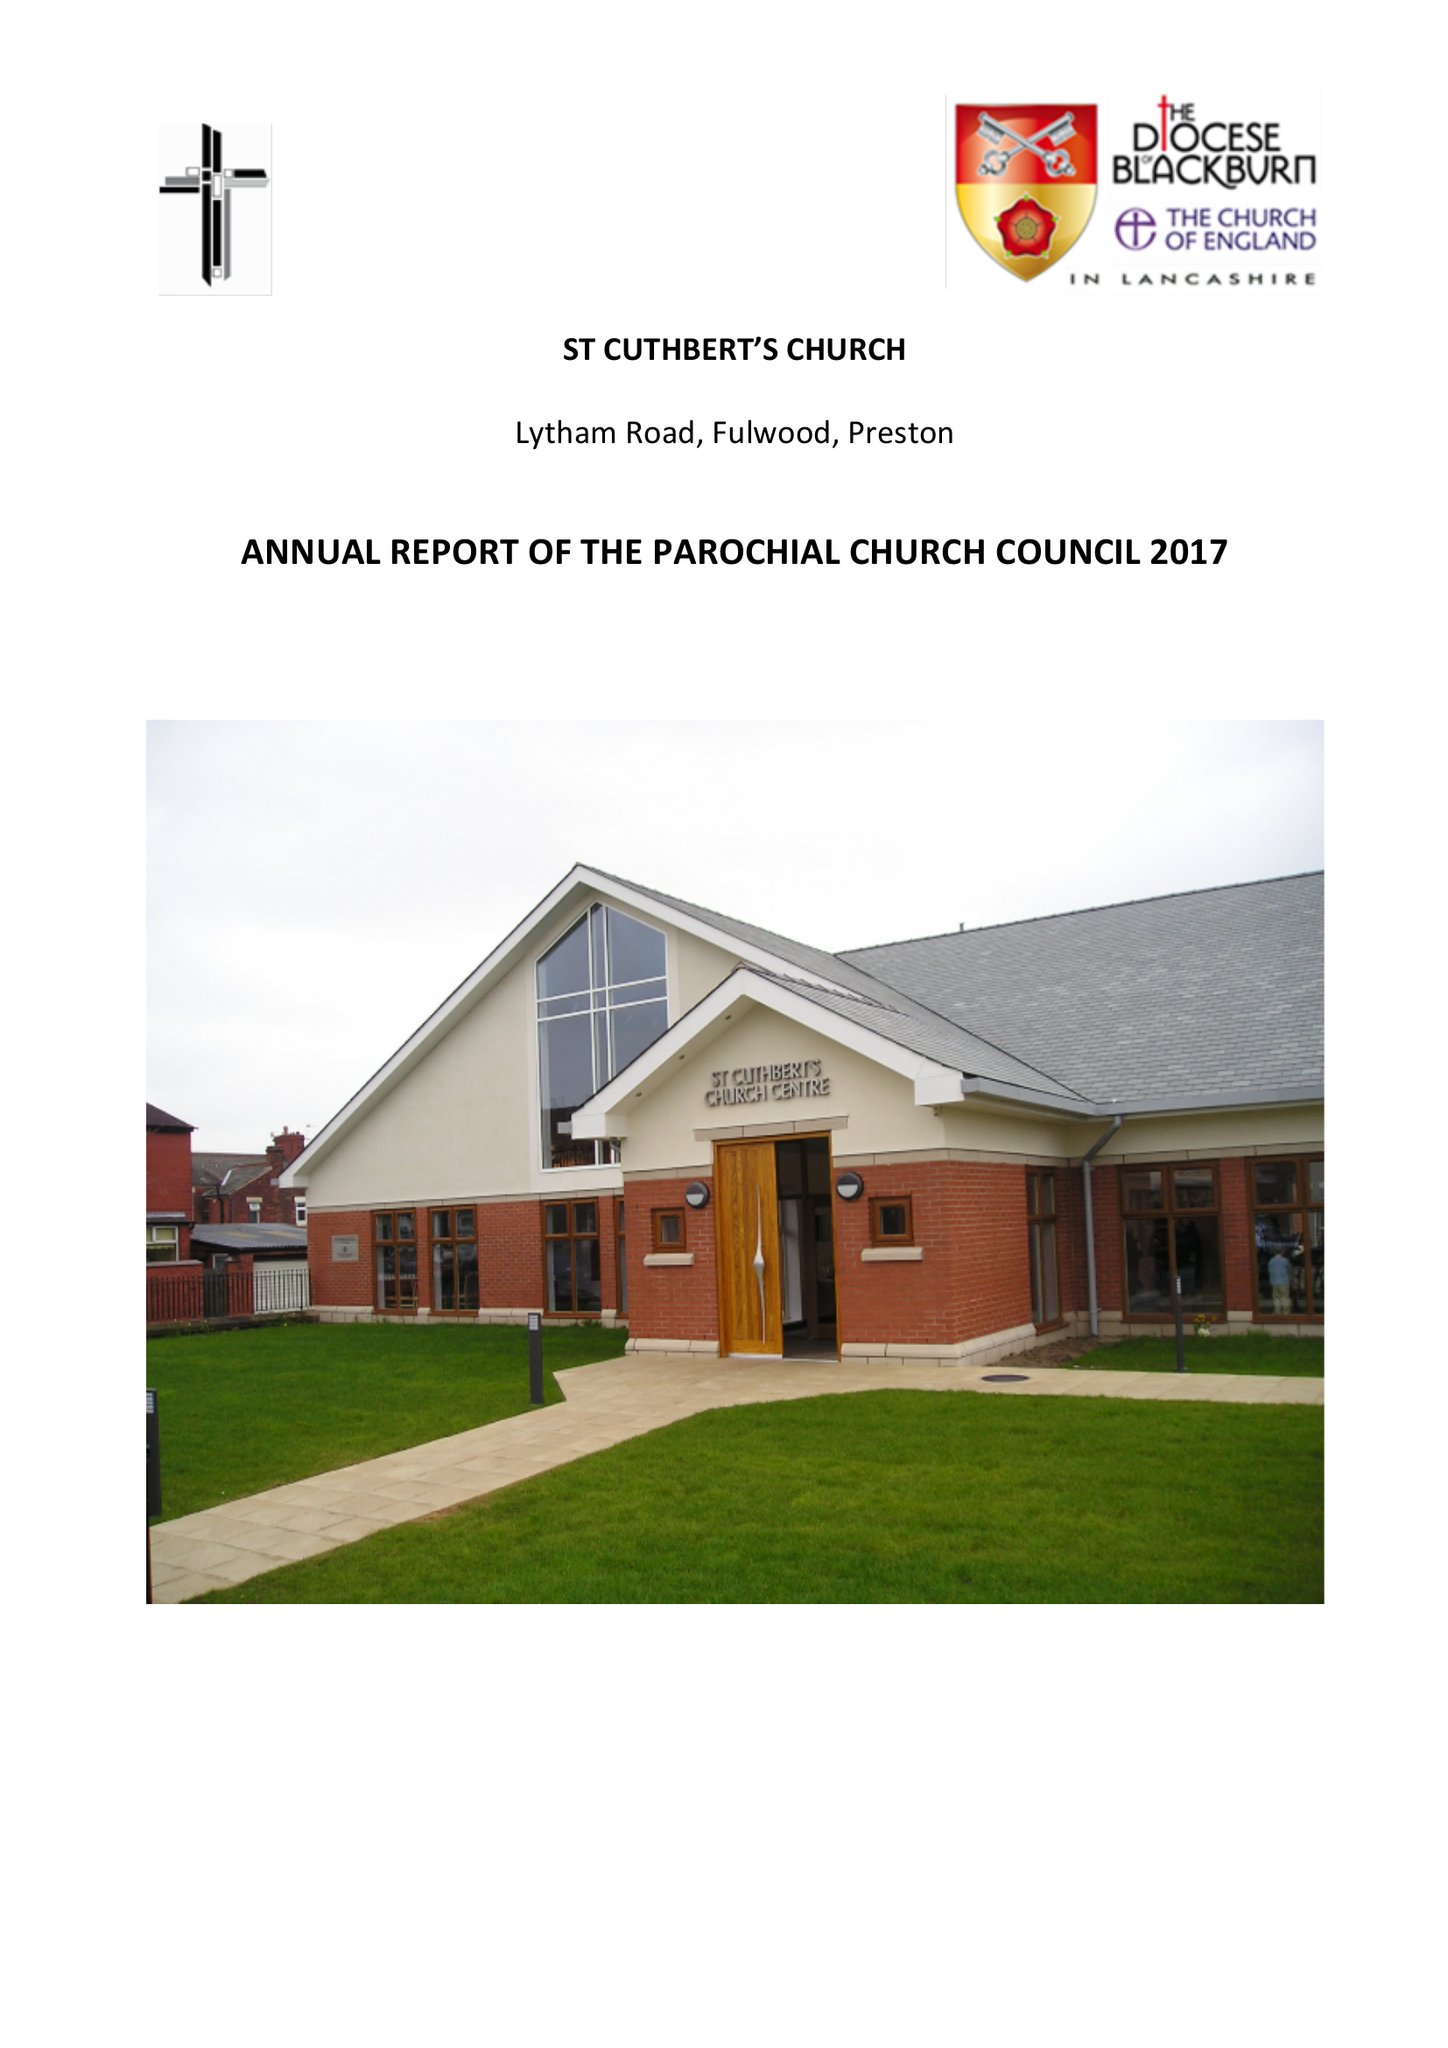What is the value for the address__street_line?
Answer the question using a single word or phrase. LYTHAM ROAD 